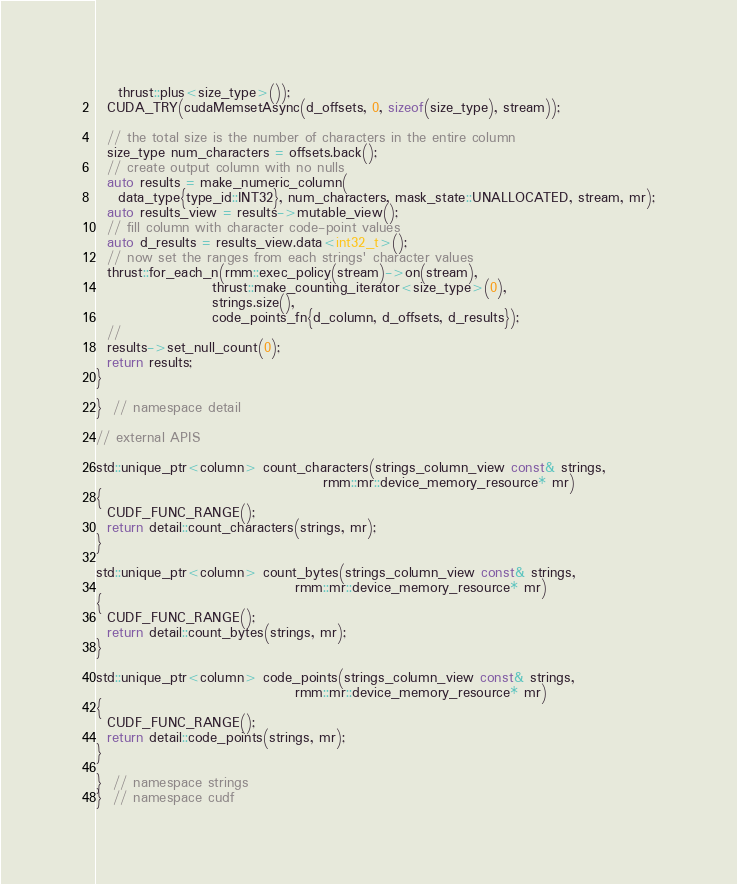<code> <loc_0><loc_0><loc_500><loc_500><_Cuda_>    thrust::plus<size_type>());
  CUDA_TRY(cudaMemsetAsync(d_offsets, 0, sizeof(size_type), stream));

  // the total size is the number of characters in the entire column
  size_type num_characters = offsets.back();
  // create output column with no nulls
  auto results = make_numeric_column(
    data_type{type_id::INT32}, num_characters, mask_state::UNALLOCATED, stream, mr);
  auto results_view = results->mutable_view();
  // fill column with character code-point values
  auto d_results = results_view.data<int32_t>();
  // now set the ranges from each strings' character values
  thrust::for_each_n(rmm::exec_policy(stream)->on(stream),
                     thrust::make_counting_iterator<size_type>(0),
                     strings.size(),
                     code_points_fn{d_column, d_offsets, d_results});
  //
  results->set_null_count(0);
  return results;
}

}  // namespace detail

// external APIS

std::unique_ptr<column> count_characters(strings_column_view const& strings,
                                         rmm::mr::device_memory_resource* mr)
{
  CUDF_FUNC_RANGE();
  return detail::count_characters(strings, mr);
}

std::unique_ptr<column> count_bytes(strings_column_view const& strings,
                                    rmm::mr::device_memory_resource* mr)
{
  CUDF_FUNC_RANGE();
  return detail::count_bytes(strings, mr);
}

std::unique_ptr<column> code_points(strings_column_view const& strings,
                                    rmm::mr::device_memory_resource* mr)
{
  CUDF_FUNC_RANGE();
  return detail::code_points(strings, mr);
}

}  // namespace strings
}  // namespace cudf
</code> 